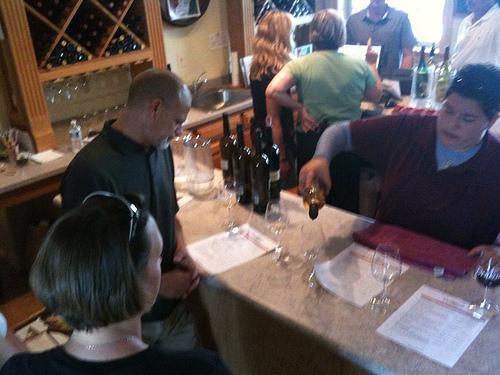Count the number of people visible in the image. There are at least four people, identified by different hairstyles, shirts, and actions they are performing. Identify one accessory worn by a woman in the image. Glasses on a woman's head. How many wine glasses are there in the image, and what are their states? There are five wine glasses, where three are empty, and two have red wine in them. What is the overall sentiment of the image given the activities and objects present? The sentiment is positive as it represents people enjoying a wine tasting event. Assess the quality of the objects included in the image provided. The quality of objects is good with clear image indicating their positions and sizes. Based on the props and setting, infer the nature of the activity that they are participating in. They are participating in a casual, social gathering centered around wine tasting and discussion. What type of event is happening in the image? People wine tasting. Analyze the interaction between the people and objects in the image. People are interacting with wine bottles, glasses, and the counter as they taste wine, pour drinks, and hold bottles. Provide a brief description of the scene captured in the image. A group of people are wine tasting, with a man pouring a drink, various bottles on the counter, and some glasses with wine. 